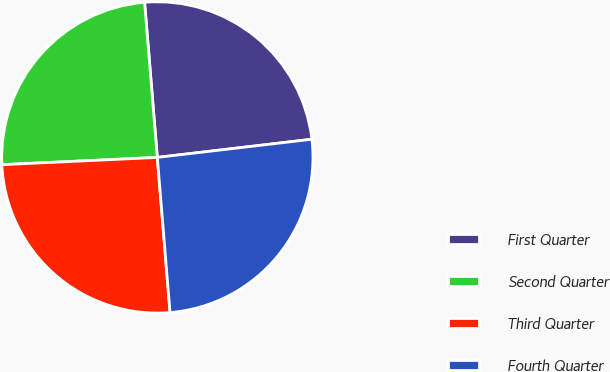Convert chart to OTSL. <chart><loc_0><loc_0><loc_500><loc_500><pie_chart><fcel>First Quarter<fcel>Second Quarter<fcel>Third Quarter<fcel>Fourth Quarter<nl><fcel>24.44%<fcel>24.44%<fcel>25.56%<fcel>25.56%<nl></chart> 